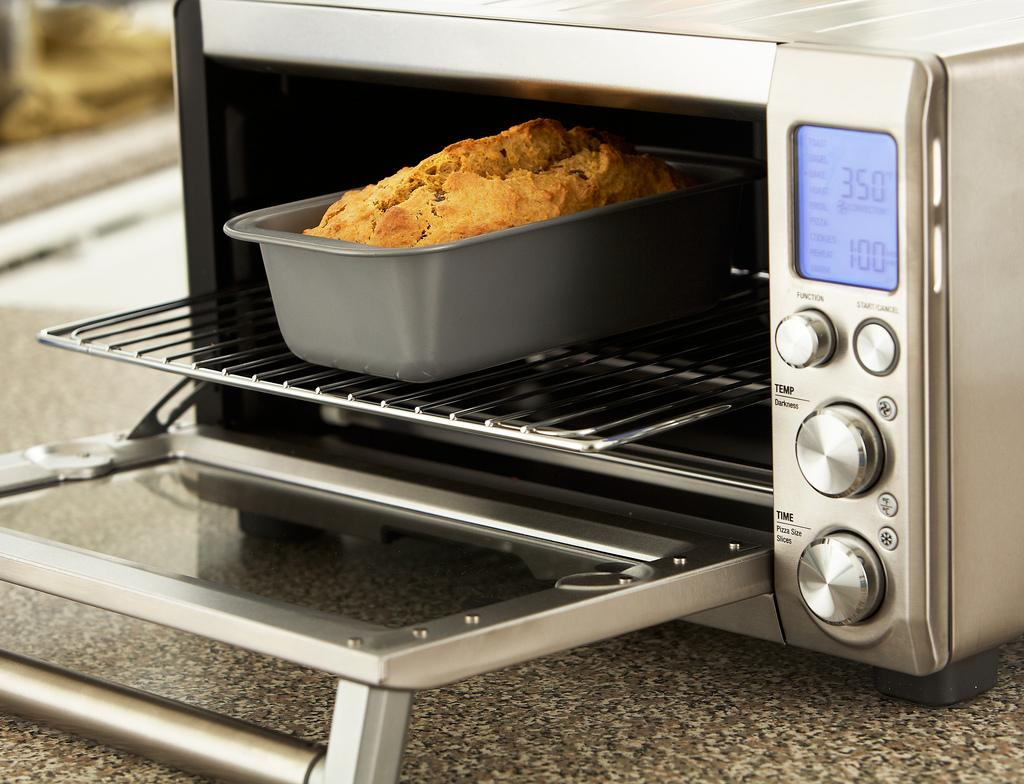<image>
Offer a succinct explanation of the picture presented. The bread is sitting in an toaster oven that is set from 350 degrees. 